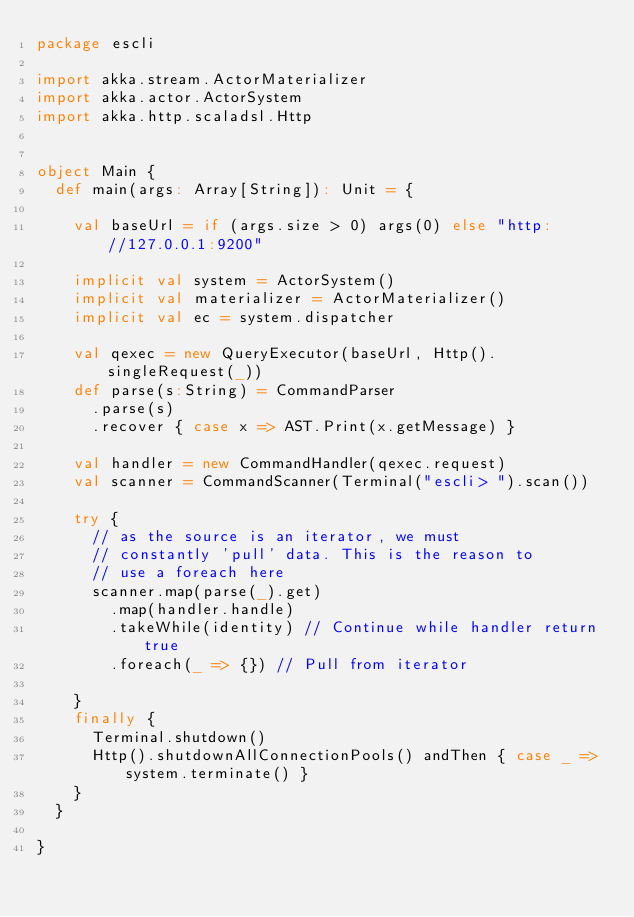Convert code to text. <code><loc_0><loc_0><loc_500><loc_500><_Scala_>package escli

import akka.stream.ActorMaterializer
import akka.actor.ActorSystem
import akka.http.scaladsl.Http


object Main {
  def main(args: Array[String]): Unit = {

    val baseUrl = if (args.size > 0) args(0) else "http://127.0.0.1:9200"

    implicit val system = ActorSystem()
    implicit val materializer = ActorMaterializer()
    implicit val ec = system.dispatcher

    val qexec = new QueryExecutor(baseUrl, Http().singleRequest(_))
    def parse(s:String) = CommandParser
      .parse(s)
      .recover { case x => AST.Print(x.getMessage) }
       
    val handler = new CommandHandler(qexec.request)
    val scanner = CommandScanner(Terminal("escli> ").scan())

    try {
      // as the source is an iterator, we must
      // constantly 'pull' data. This is the reason to
      // use a foreach here
      scanner.map(parse(_).get)
        .map(handler.handle)
        .takeWhile(identity) // Continue while handler return true
        .foreach(_ => {}) // Pull from iterator  

    }
    finally {
      Terminal.shutdown()
      Http().shutdownAllConnectionPools() andThen { case _ => system.terminate() }
    }
  }

}
</code> 